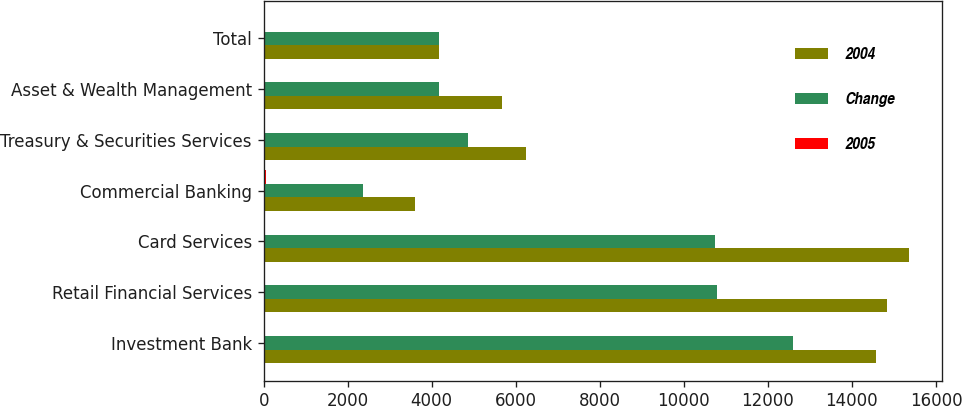<chart> <loc_0><loc_0><loc_500><loc_500><stacked_bar_chart><ecel><fcel>Investment Bank<fcel>Retail Financial Services<fcel>Card Services<fcel>Commercial Banking<fcel>Treasury & Securities Services<fcel>Asset & Wealth Management<fcel>Total<nl><fcel>2004<fcel>14578<fcel>14830<fcel>15366<fcel>3596<fcel>6241<fcel>5664<fcel>4179<nl><fcel>Change<fcel>12605<fcel>10791<fcel>10745<fcel>2374<fcel>4857<fcel>4179<fcel>4179<nl><fcel>2005<fcel>16<fcel>37<fcel>43<fcel>51<fcel>28<fcel>36<fcel>27<nl></chart> 